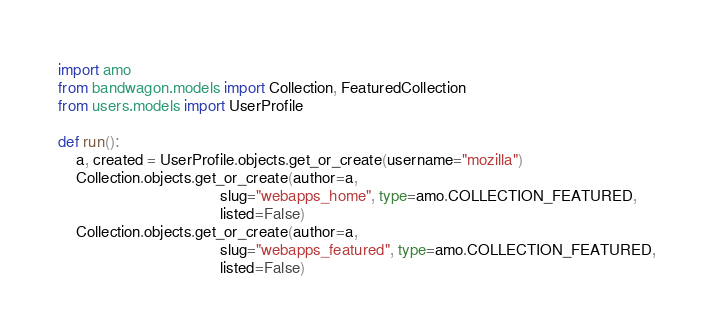Convert code to text. <code><loc_0><loc_0><loc_500><loc_500><_Python_>import amo
from bandwagon.models import Collection, FeaturedCollection
from users.models import UserProfile

def run():
    a, created = UserProfile.objects.get_or_create(username="mozilla")
    Collection.objects.get_or_create(author=a,
                                     slug="webapps_home", type=amo.COLLECTION_FEATURED,
                                     listed=False)
    Collection.objects.get_or_create(author=a,
                                     slug="webapps_featured", type=amo.COLLECTION_FEATURED,
                                     listed=False)
</code> 